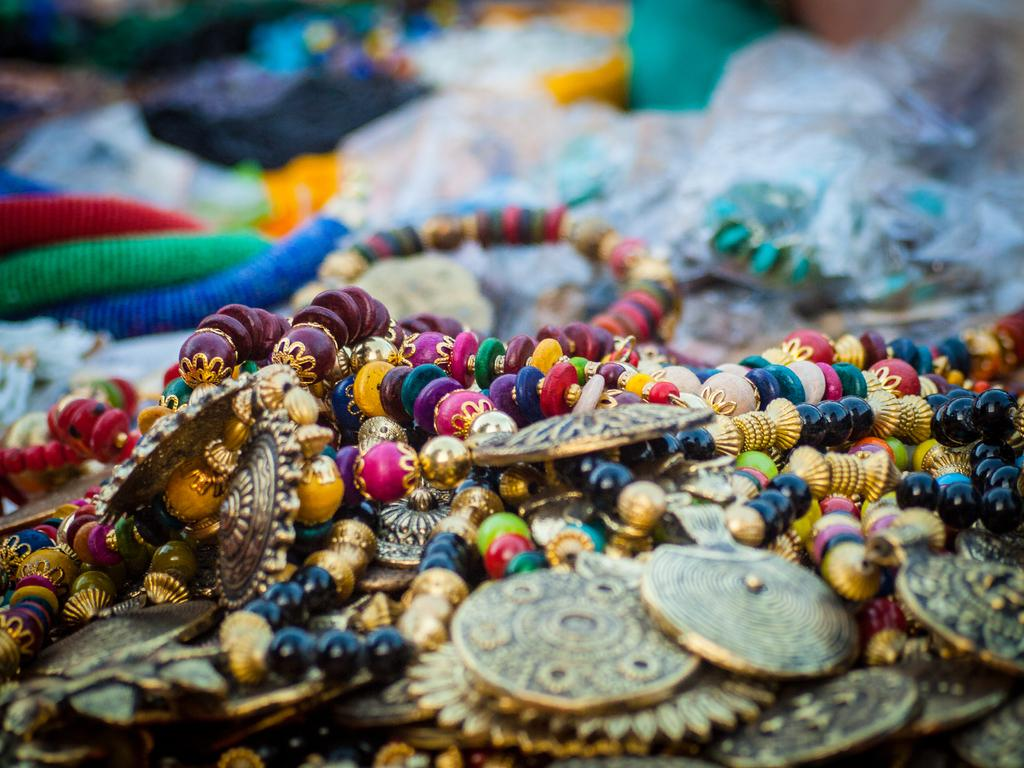What type of item is featured in the image? There is jewelry in the image. Can you see a cow in the image? No, there is no cow present in the image. 